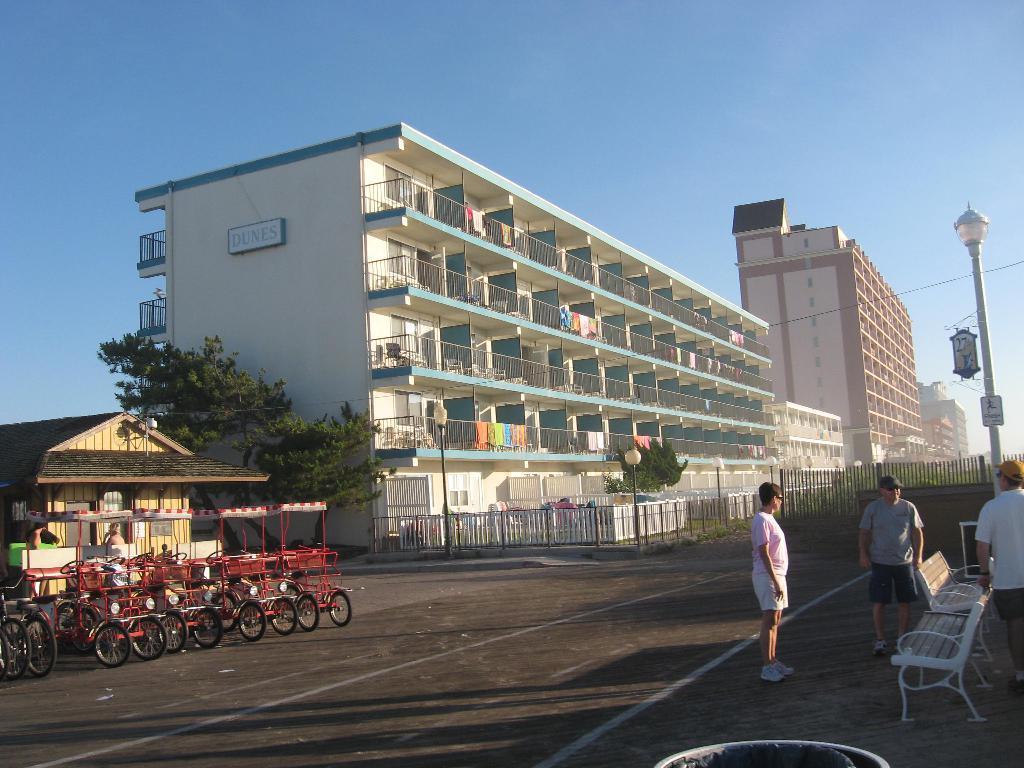Describe this image in one or two sentences. In this picture there are buildings in the image and there are people on the right side of the image and there are cycle carts on the left side of the image, there is a pole on the right side of the image and there is a house on the left side of the image, there are few trees in the image and a boundary in the image. 